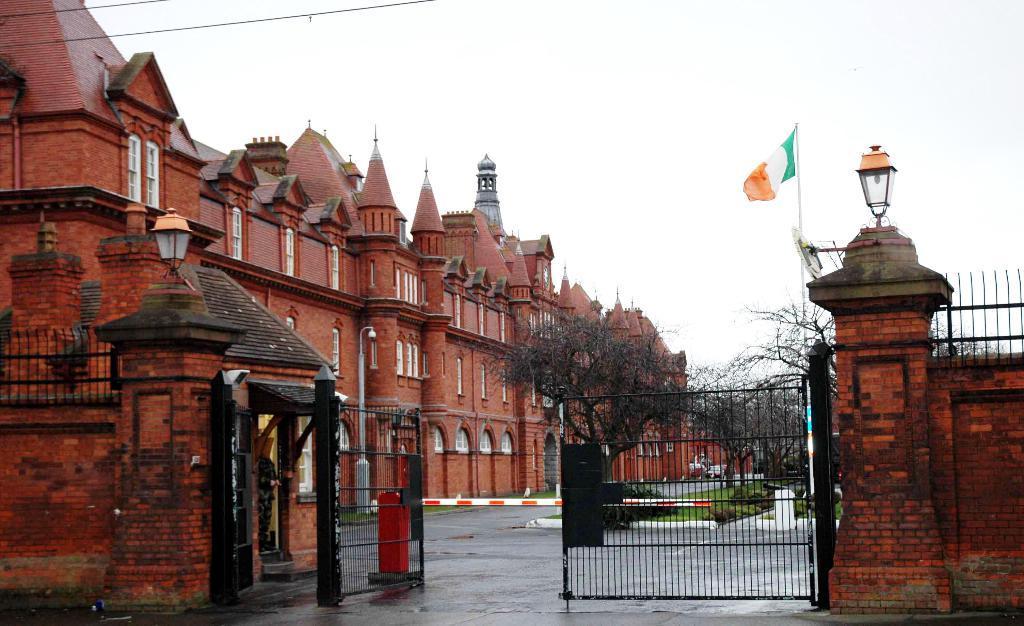In one or two sentences, can you explain what this image depicts? In this image there is a huge building, in front of the building there is a vehicle, trees, grass, plants and there is a flag. In the foreground of the image there is a wall and a gate. On the wall there are two lamps. In the background there is the sky 